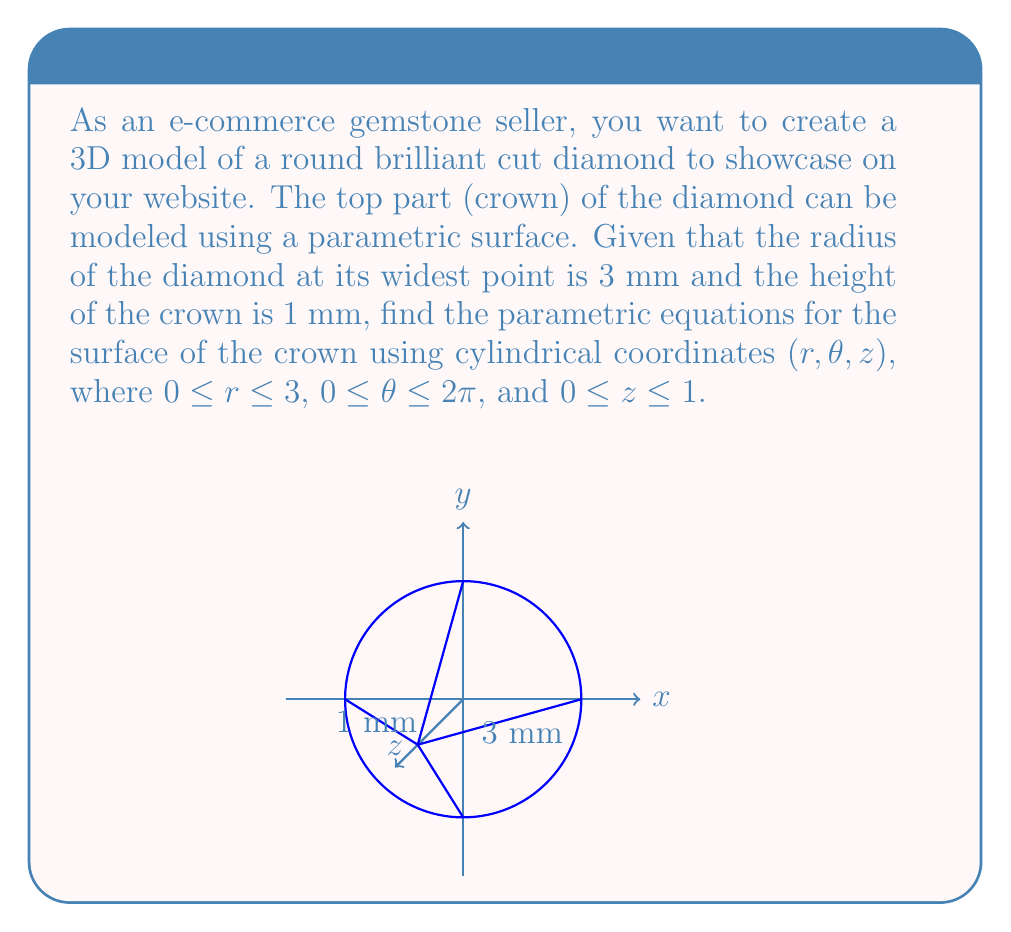Can you answer this question? Let's approach this step-by-step:

1) In cylindrical coordinates, we have:
   $x = r \cos(\theta)$
   $y = r \sin(\theta)$
   $z = f(r)$, where $f(r)$ is a function we need to determine

2) We know that:
   - At the widest point, $r = 3$ and $z = 0$
   - At the top of the crown, $r = 0$ and $z = 1$

3) We need a linear function that satisfies these conditions. The general form is:
   $z = mr + b$

4) Substituting the known points:
   When $r = 3$, $z = 0$: $0 = 3m + b$
   When $r = 0$, $z = 1$: $1 = 0 + b$

5) From the second equation, we know $b = 1$. Substituting this into the first equation:
   $0 = 3m + 1$
   $-1 = 3m$
   $m = -1/3$

6) Therefore, our $z$ function is:
   $z = -\frac{1}{3}r + 1$

7) Now we can write our parametric equations:
   $x = r \cos(\theta)$
   $y = r \sin(\theta)$
   $z = -\frac{1}{3}r + 1$

8) The domain for the parameters is:
   $0 \leq r \leq 3$
   $0 \leq \theta \leq 2\pi$
Answer: $x = r \cos(\theta)$, $y = r \sin(\theta)$, $z = -\frac{1}{3}r + 1$, where $0 \leq r \leq 3$, $0 \leq \theta \leq 2\pi$ 